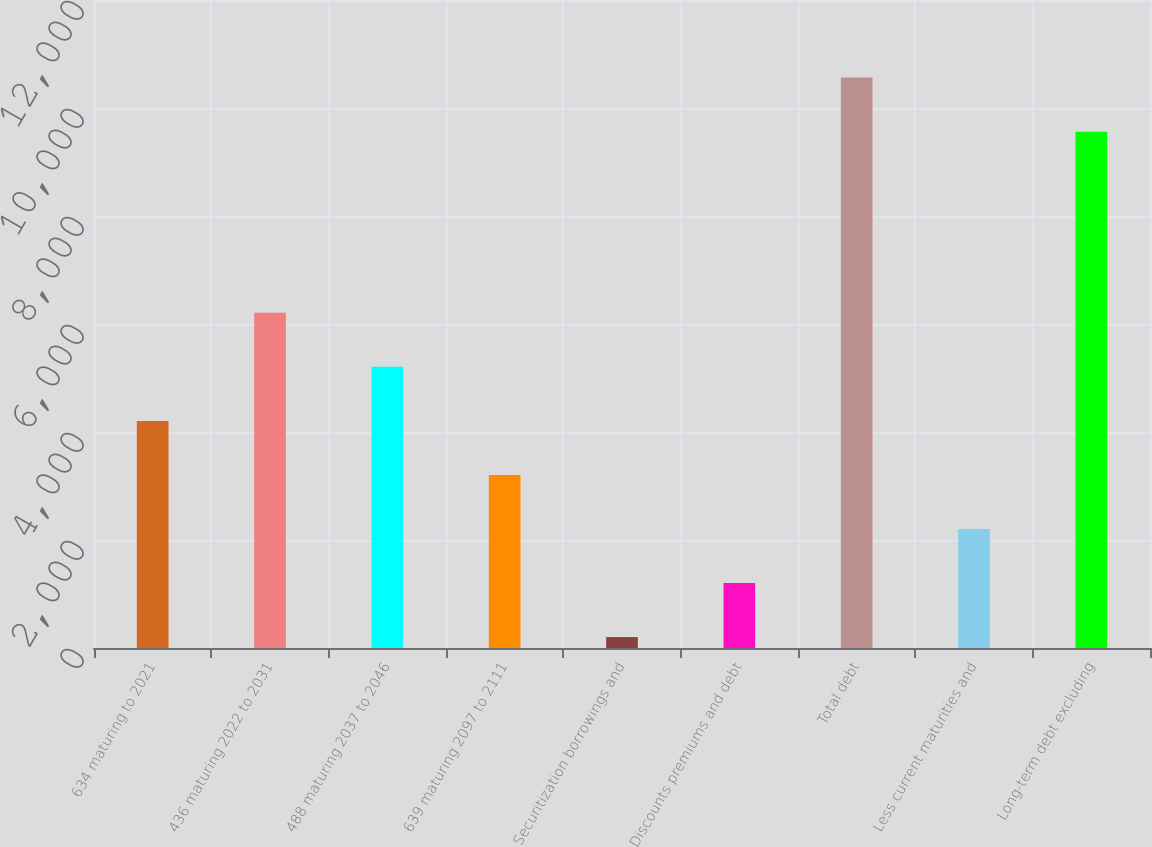Convert chart. <chart><loc_0><loc_0><loc_500><loc_500><bar_chart><fcel>634 maturing to 2021<fcel>436 maturing 2022 to 2031<fcel>488 maturing 2037 to 2046<fcel>639 maturing 2097 to 2111<fcel>Securitization borrowings and<fcel>Discounts premiums and debt<fcel>Total debt<fcel>Less current maturities and<fcel>Long-term debt excluding<nl><fcel>4206<fcel>6208<fcel>5207<fcel>3205<fcel>202<fcel>1203<fcel>10563<fcel>2204<fcel>9562<nl></chart> 